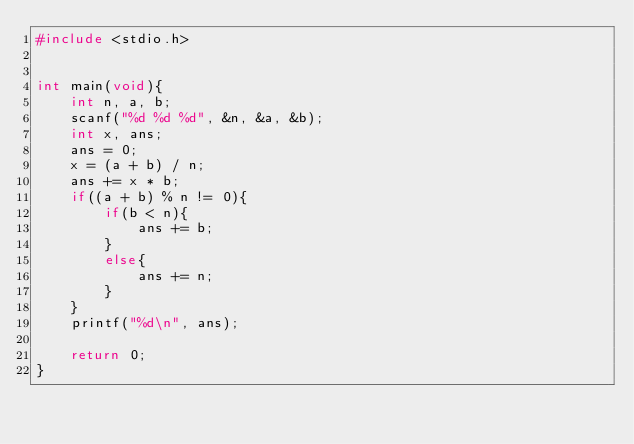<code> <loc_0><loc_0><loc_500><loc_500><_C_>#include <stdio.h>


int main(void){
    int n, a, b;
    scanf("%d %d %d", &n, &a, &b);
    int x, ans;
    ans = 0;
    x = (a + b) / n;
    ans += x * b;
    if((a + b) % n != 0){
        if(b < n){
            ans += b;
        }
        else{
            ans += n;
        }
    }
    printf("%d\n", ans);

    return 0;
}</code> 